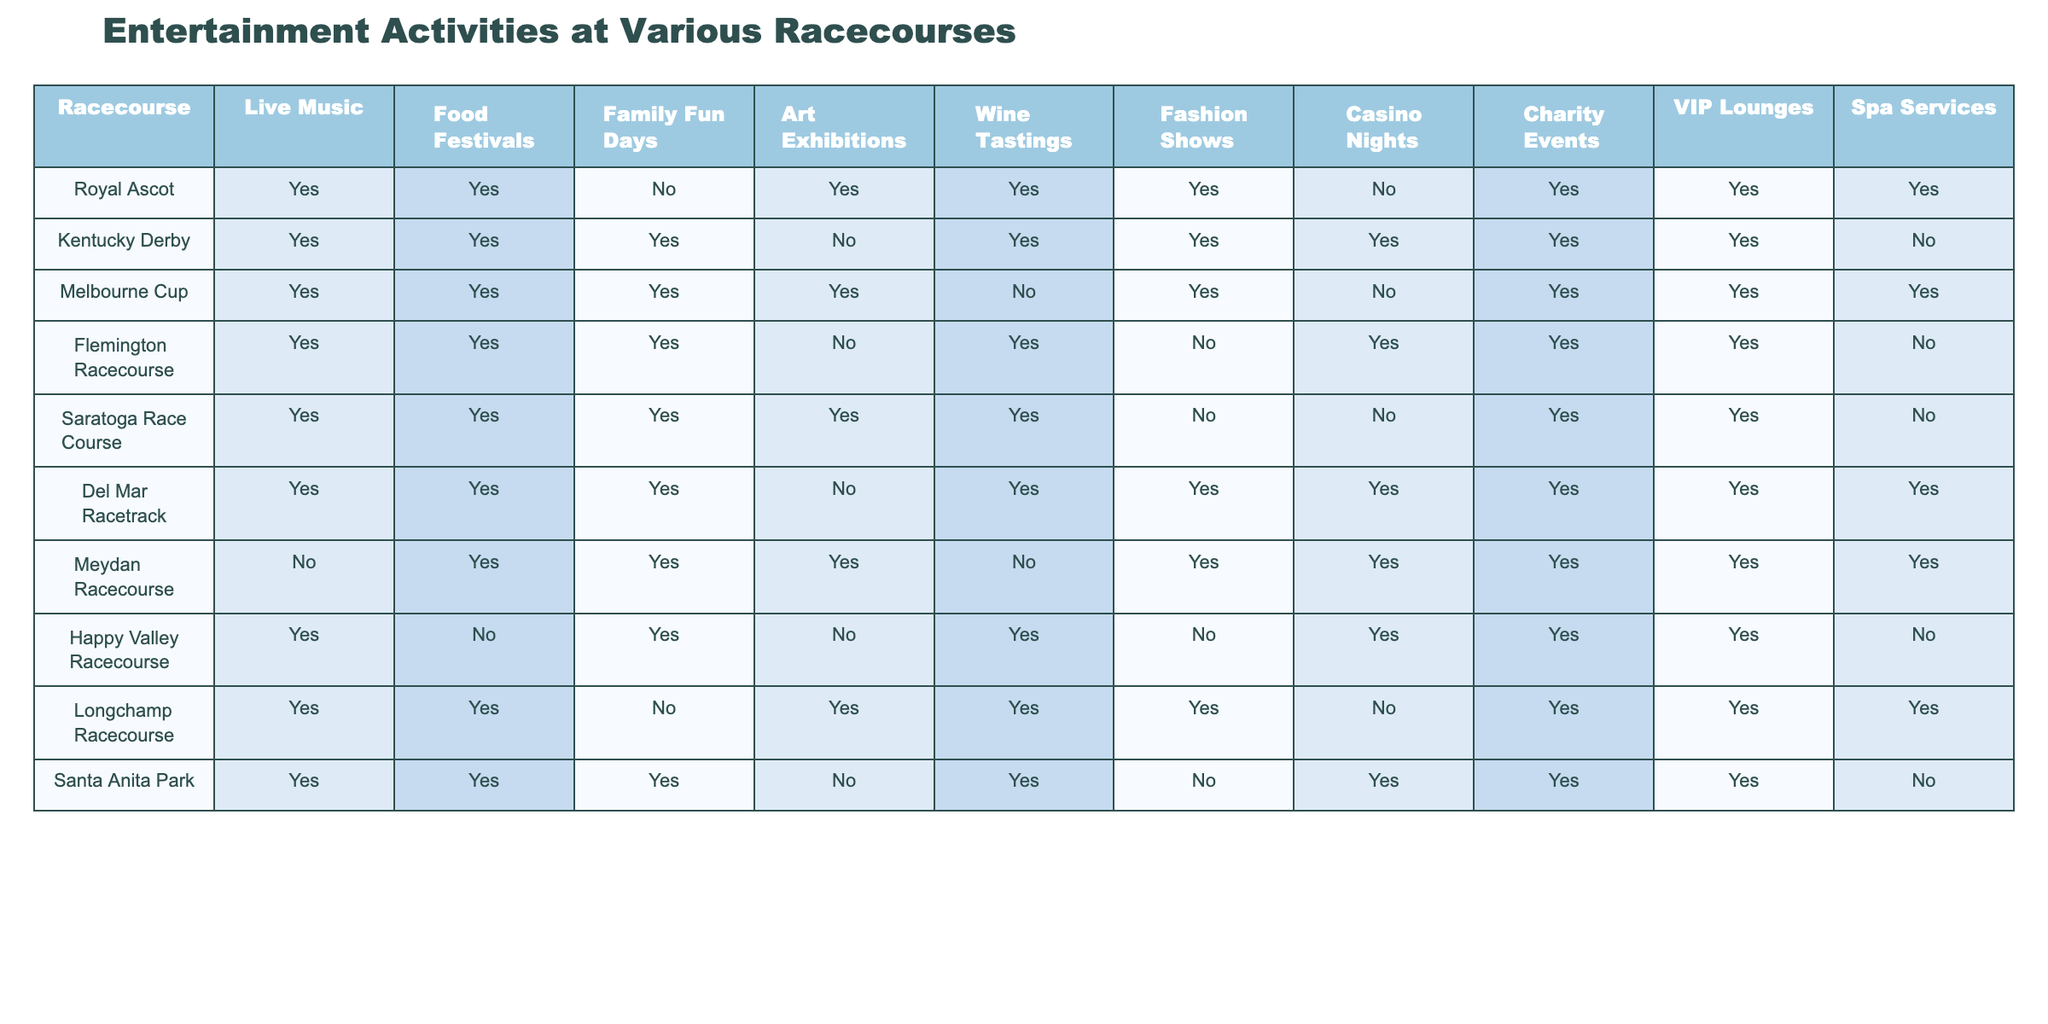What racecourses offer Family Fun Days? From the table, we can see which racecourses have the "Family Fun Days" column marked "Yes". By checking each racecourse, we find that the ones offering this activity are Kentucky Derby, Melbourne Cup, Flemington Racecourse, Saratoga Race Course, Del Mar Racetrack, Meydan Racecourse, Happy Valley Racecourse, and Santa Anita Park.
Answer: Kentucky Derby, Melbourne Cup, Flemington Racecourse, Saratoga Race Course, Del Mar Racetrack, Meydan Racecourse, Happy Valley Racecourse, Santa Anita Park Which racecourse has the most attractions? To determine which racecourse has the most "Yes" responses, we need to count the "Yes" entries for each row. Counting reveals that the Del Mar Racetrack and Meydan Racecourse both have 10 Yes entries, which is the highest among all.
Answer: Del Mar Racetrack, Meydan Racecourse Is Live Music offered at the Royal Ascot? The table indicates whether Live Music is provided at each racecourse. For the Royal Ascot, it shows "Yes" in the Live Music column.
Answer: Yes How many racecourses offer Casino Nights? We count the entries in the Casino Nights column marked "Yes". By inspection, we find that five racecourses offer Casino Nights: Kentucky Derby, Flemington Racecourse, Del Mar Racetrack, Meydan Racecourse, and Happy Valley Racecourse.
Answer: Five Which activity is least offered across all racecourses? To find the activity with the least "Yes" responses, we review each column and tally the "Yes" counts. The activity with the least offerings is Art Exhibitions, which is only offered at Royal Ascot, Melbourne Cup, Longchamp Racecourse, and Santa Anita Park (4 total).
Answer: Art Exhibitions How many racecourses offer both Food Festivals and Wine Tastings? We look for rows where both Food Festivals and Wine Tastings have "Yes". By inspecting the table, we find there are six racecourses that fall into this category: Royal Ascot, Kentucky Derby, Flemington Racecourse, Del Mar Racetrack, Meydan Racecourse, and Longchamp Racecourse.
Answer: Six Are there any racecourses without VIP Lounges? We check the VIP Lounges column for any "No" entries. The table shows that the Kentucky Derby and Santa Anita Park do not have VIP Lounges.
Answer: Yes What is the total number of different entertainment activities offered at the Kentucky Derby? We count the number of "Yes" in the Kentucky Derby row. There are seven activities marked as "Yes", which indicates the total offered.
Answer: Seven Which racecourse offers the most variety for social events and gatherings? We need to assess which racecourse has the highest number of distinct activities, or "Yes" responses overall. Counting across each row reveals that Del Mar Racetrack and Meydan Racecourse provide the most variety, with 10 activities each.
Answer: Del Mar Racetrack, Meydan Racecourse Is there any racecourse that has Spa Services but not VIP Lounges? The table must be inspected for the Spa Services and VIP Lounges columns to identify any "Yes" and "No" patterns. Only the Kentucky Derby meets this criteria, having Spa Services and lacking VIP Lounges.
Answer: Yes Which two attractions are most commonly found together across the racecourses? To deduce which pair of activities occurs most often together, we must analyze and compare the columns for alignment between "Yes" responses. Upon analyzing, we see that Food Festivals and Wine Tastings are both offered together in most cases, appearing together in seven different racecourses.
Answer: Food Festivals and Wine Tastings 